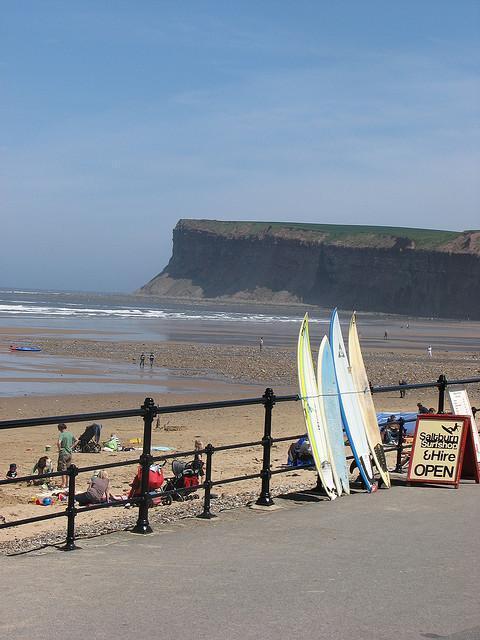How many boards are lined up?
Give a very brief answer. 4. How many surfboards are in the photo?
Give a very brief answer. 4. 